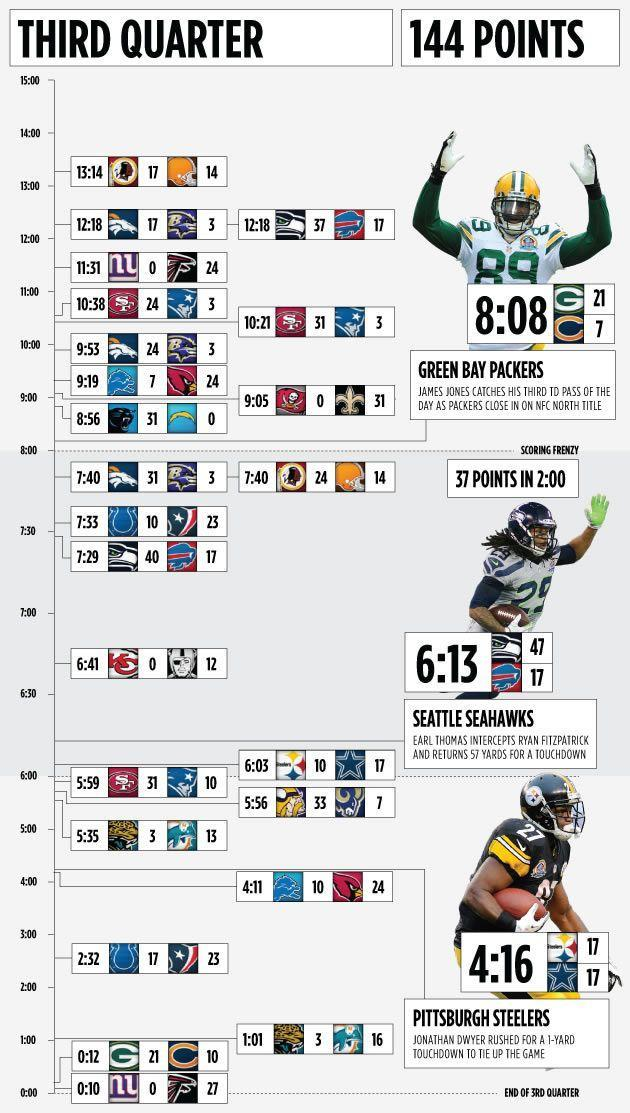Which team scored 21 points at 8:08, Chicago Bears, Green Bay Packers, or  New York Giants?
Answer the question with a short phrase. Green Bay Packers Which were the two teams that scored 17 at 12:18? Denver Broncos, Buffalo Bills Who is the player in the jersey number 29? Earl Thomas Which Player wears jersey number 27? Jonathan Dwyer 